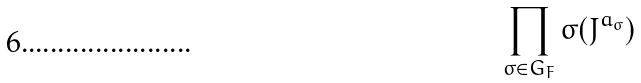Convert formula to latex. <formula><loc_0><loc_0><loc_500><loc_500>\prod _ { \sigma \in G _ { F } } \sigma ( J ^ { a _ { \sigma } } )</formula> 